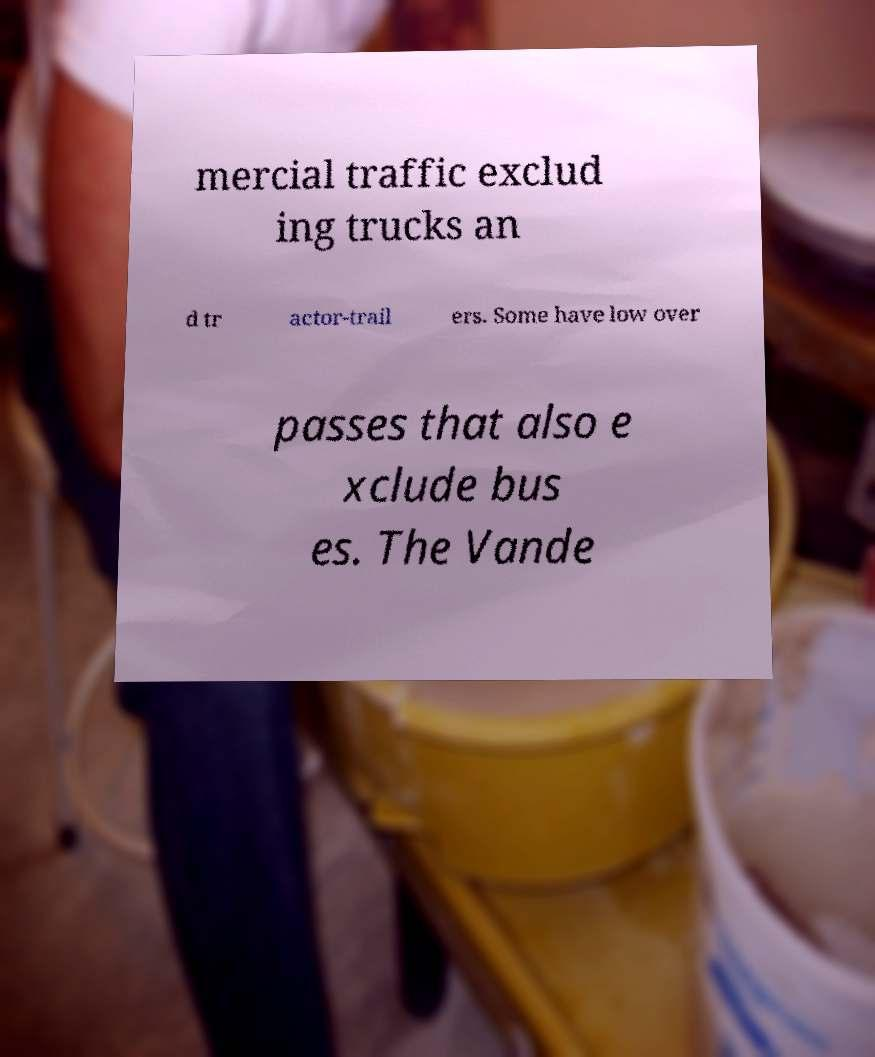Can you read and provide the text displayed in the image?This photo seems to have some interesting text. Can you extract and type it out for me? mercial traffic exclud ing trucks an d tr actor-trail ers. Some have low over passes that also e xclude bus es. The Vande 